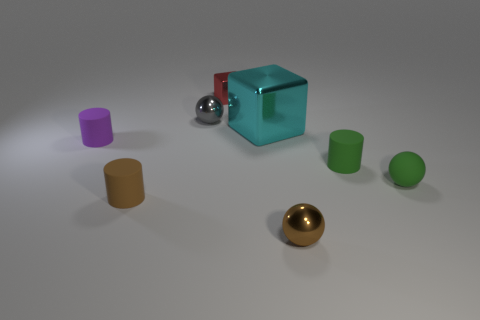Add 1 brown objects. How many objects exist? 9 Subtract all cylinders. How many objects are left? 5 Subtract 0 brown cubes. How many objects are left? 8 Subtract all brown rubber cylinders. Subtract all cyan cubes. How many objects are left? 6 Add 8 small brown metal things. How many small brown metal things are left? 9 Add 7 green matte cylinders. How many green matte cylinders exist? 8 